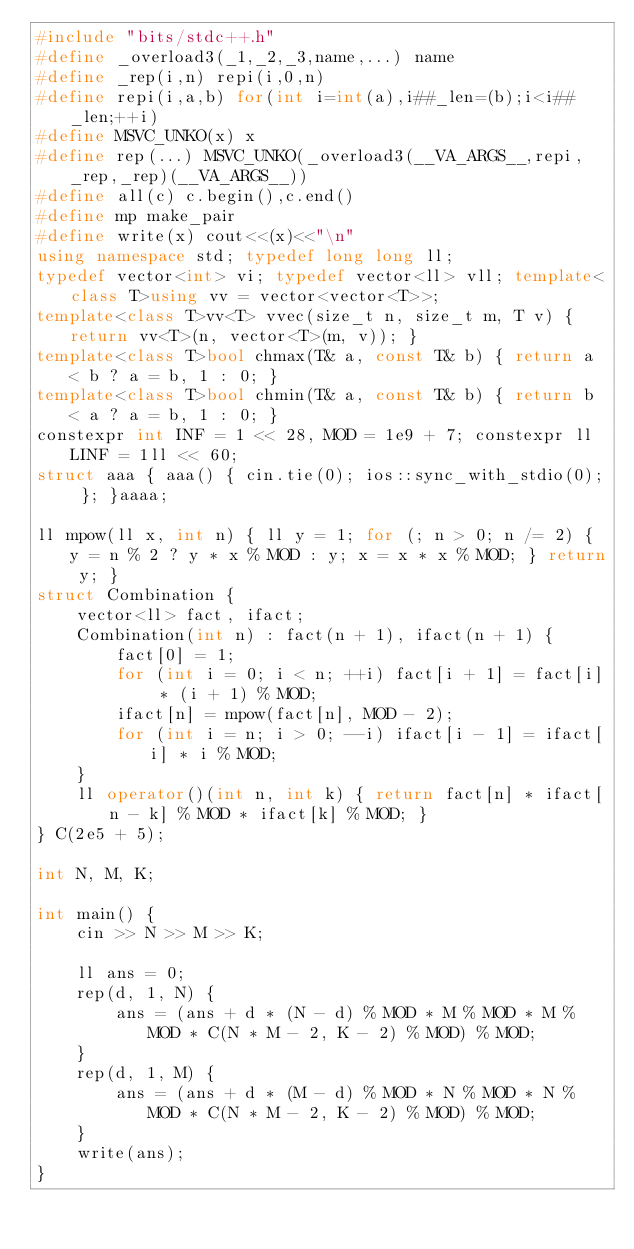<code> <loc_0><loc_0><loc_500><loc_500><_C++_>#include "bits/stdc++.h"
#define _overload3(_1,_2,_3,name,...) name
#define _rep(i,n) repi(i,0,n)
#define repi(i,a,b) for(int i=int(a),i##_len=(b);i<i##_len;++i)
#define MSVC_UNKO(x) x
#define rep(...) MSVC_UNKO(_overload3(__VA_ARGS__,repi,_rep,_rep)(__VA_ARGS__))
#define all(c) c.begin(),c.end()
#define mp make_pair
#define write(x) cout<<(x)<<"\n"
using namespace std; typedef long long ll;
typedef vector<int> vi; typedef vector<ll> vll; template<class T>using vv = vector<vector<T>>;
template<class T>vv<T> vvec(size_t n, size_t m, T v) { return vv<T>(n, vector<T>(m, v)); }
template<class T>bool chmax(T& a, const T& b) { return a < b ? a = b, 1 : 0; }
template<class T>bool chmin(T& a, const T& b) { return b < a ? a = b, 1 : 0; }
constexpr int INF = 1 << 28, MOD = 1e9 + 7; constexpr ll LINF = 1ll << 60;
struct aaa { aaa() { cin.tie(0); ios::sync_with_stdio(0); }; }aaaa;

ll mpow(ll x, int n) { ll y = 1; for (; n > 0; n /= 2) { y = n % 2 ? y * x % MOD : y; x = x * x % MOD; } return y; }
struct Combination {
    vector<ll> fact, ifact;
    Combination(int n) : fact(n + 1), ifact(n + 1) {
        fact[0] = 1;
        for (int i = 0; i < n; ++i) fact[i + 1] = fact[i] * (i + 1) % MOD;
        ifact[n] = mpow(fact[n], MOD - 2);
        for (int i = n; i > 0; --i) ifact[i - 1] = ifact[i] * i % MOD;
    }
    ll operator()(int n, int k) { return fact[n] * ifact[n - k] % MOD * ifact[k] % MOD; }
} C(2e5 + 5);

int N, M, K;

int main() {
    cin >> N >> M >> K;

    ll ans = 0;
    rep(d, 1, N) {
        ans = (ans + d * (N - d) % MOD * M % MOD * M % MOD * C(N * M - 2, K - 2) % MOD) % MOD;
    }
    rep(d, 1, M) {
        ans = (ans + d * (M - d) % MOD * N % MOD * N % MOD * C(N * M - 2, K - 2) % MOD) % MOD;
    }
    write(ans);
}</code> 